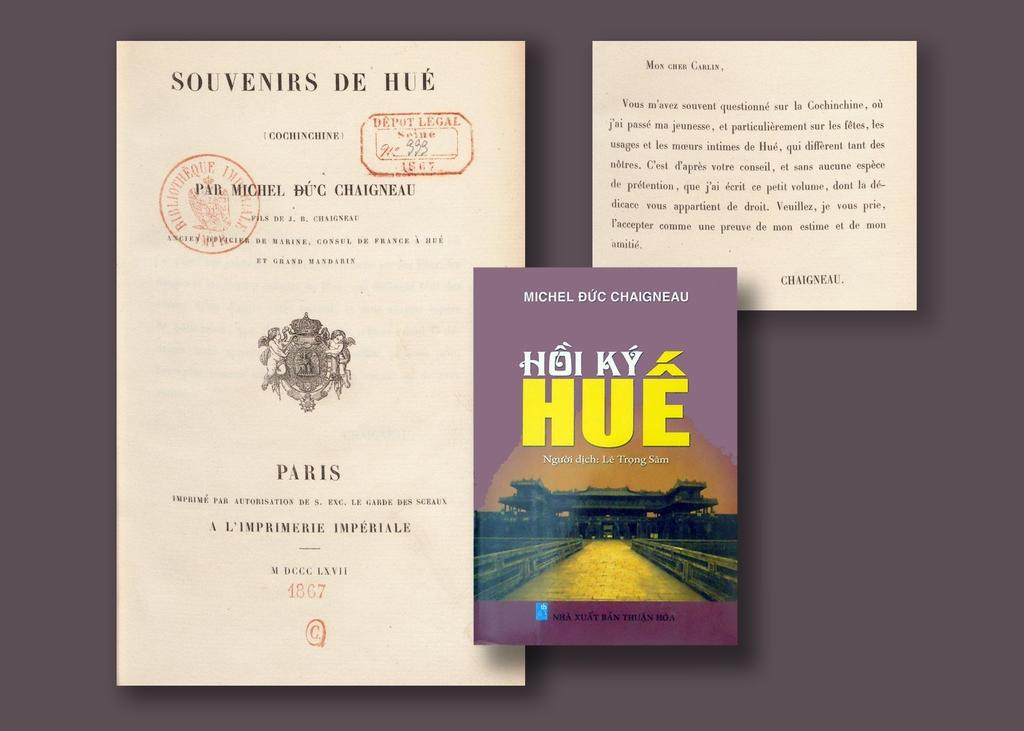<image>
Summarize the visual content of the image. A purple book called Hoi Ky Hue by Michel Buc Chaigneau 